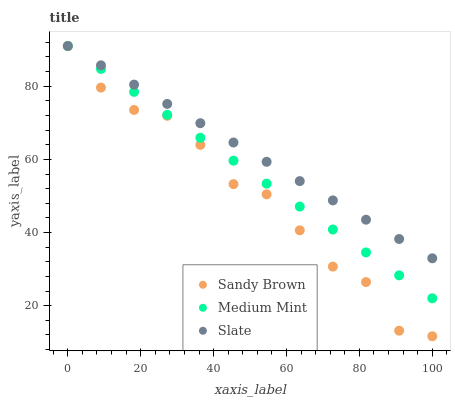Does Sandy Brown have the minimum area under the curve?
Answer yes or no. Yes. Does Slate have the maximum area under the curve?
Answer yes or no. Yes. Does Slate have the minimum area under the curve?
Answer yes or no. No. Does Sandy Brown have the maximum area under the curve?
Answer yes or no. No. Is Medium Mint the smoothest?
Answer yes or no. Yes. Is Sandy Brown the roughest?
Answer yes or no. Yes. Is Slate the smoothest?
Answer yes or no. No. Is Slate the roughest?
Answer yes or no. No. Does Sandy Brown have the lowest value?
Answer yes or no. Yes. Does Slate have the lowest value?
Answer yes or no. No. Does Sandy Brown have the highest value?
Answer yes or no. Yes. Does Medium Mint intersect Sandy Brown?
Answer yes or no. Yes. Is Medium Mint less than Sandy Brown?
Answer yes or no. No. Is Medium Mint greater than Sandy Brown?
Answer yes or no. No. 